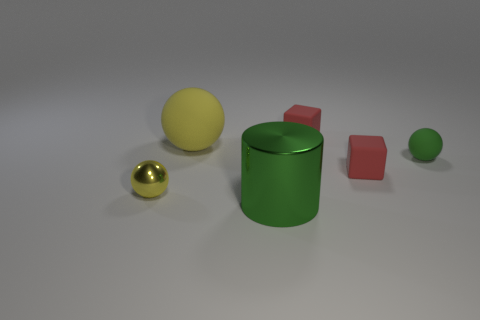What is the material of the green object that is the same shape as the big yellow rubber object?
Make the answer very short. Rubber. What number of objects are either rubber spheres that are to the left of the metal cylinder or tiny metal cubes?
Your answer should be compact. 1. What number of other objects are the same size as the metallic cylinder?
Offer a very short reply. 1. There is a tiny sphere that is to the left of the big object that is in front of the yellow sphere in front of the green matte thing; what is it made of?
Your response must be concise. Metal. What number of balls are either green shiny things or yellow objects?
Ensure brevity in your answer.  2. Is there any other thing that is the same shape as the large metallic thing?
Your answer should be very brief. No. Is the number of small green spheres behind the green metallic thing greater than the number of small green spheres in front of the small metal thing?
Your response must be concise. Yes. What number of small red rubber blocks are behind the large object that is behind the metal ball?
Your answer should be compact. 1. What number of things are either brown balls or small green objects?
Ensure brevity in your answer.  1. Does the tiny metallic thing have the same shape as the green rubber thing?
Give a very brief answer. Yes. 